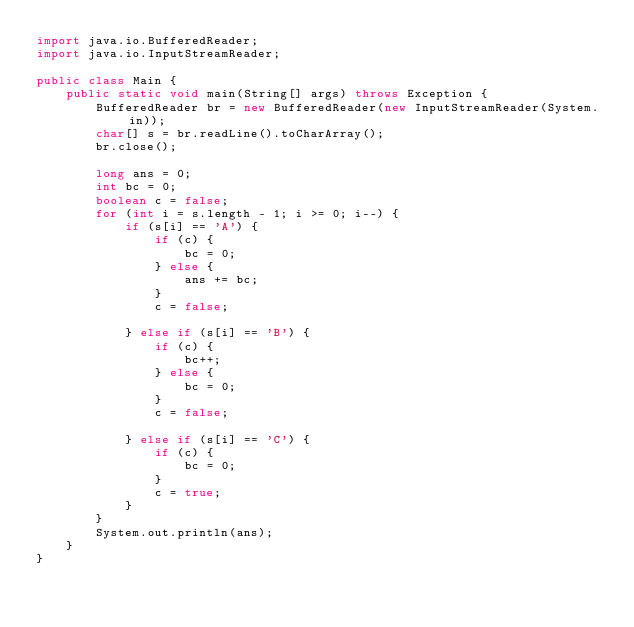<code> <loc_0><loc_0><loc_500><loc_500><_Java_>import java.io.BufferedReader;
import java.io.InputStreamReader;

public class Main {
	public static void main(String[] args) throws Exception {
		BufferedReader br = new BufferedReader(new InputStreamReader(System.in));
		char[] s = br.readLine().toCharArray();
		br.close();

		long ans = 0;
		int bc = 0;
		boolean c = false;
		for (int i = s.length - 1; i >= 0; i--) {
			if (s[i] == 'A') {
				if (c) {
					bc = 0;
				} else {
					ans += bc;
				}
				c = false;

			} else if (s[i] == 'B') {
				if (c) {
					bc++;
				} else {
					bc = 0;
				}
				c = false;

			} else if (s[i] == 'C') {
				if (c) {
					bc = 0;
				}
				c = true;
			}
		}
		System.out.println(ans);
	}
}
</code> 